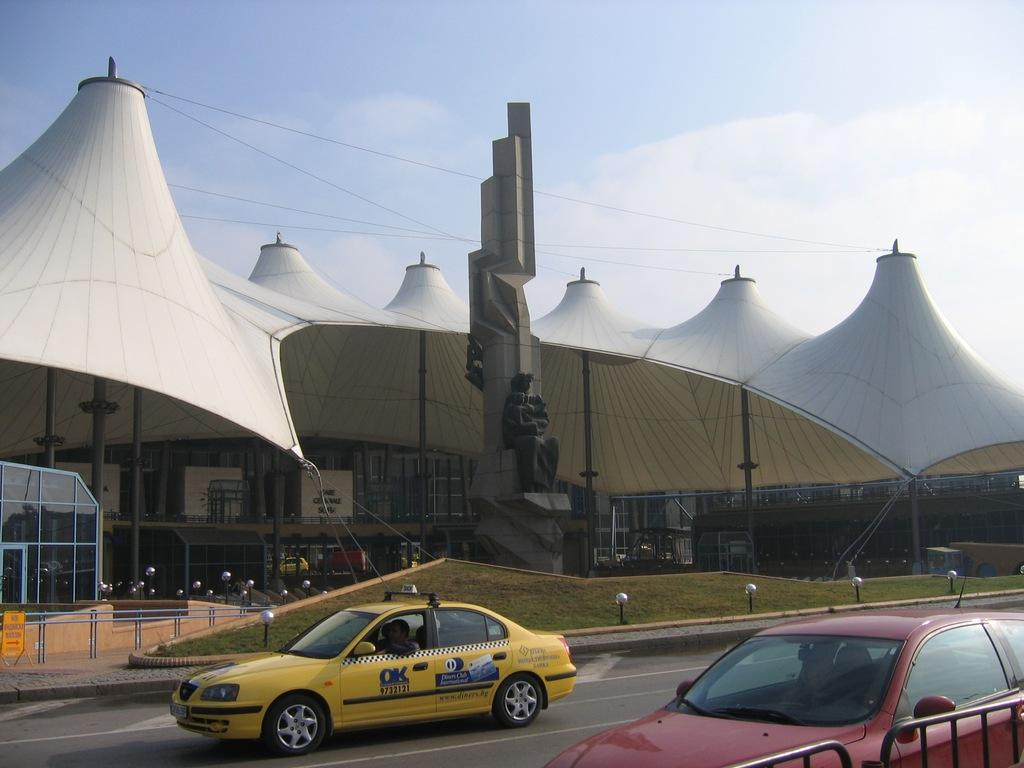<image>
Offer a succinct explanation of the picture presented. the word ok on the cab that is on the street 